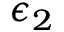Convert formula to latex. <formula><loc_0><loc_0><loc_500><loc_500>\epsilon _ { 2 }</formula> 